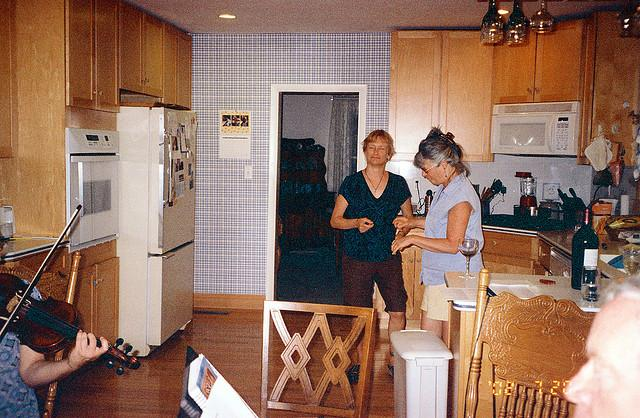What instrument is the person on the left playing? violin 